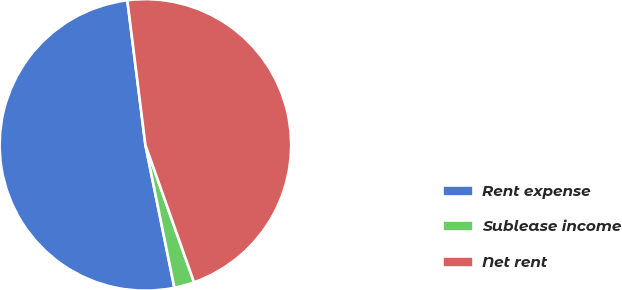<chart> <loc_0><loc_0><loc_500><loc_500><pie_chart><fcel>Rent expense<fcel>Sublease income<fcel>Net rent<nl><fcel>51.21%<fcel>2.23%<fcel>46.56%<nl></chart> 